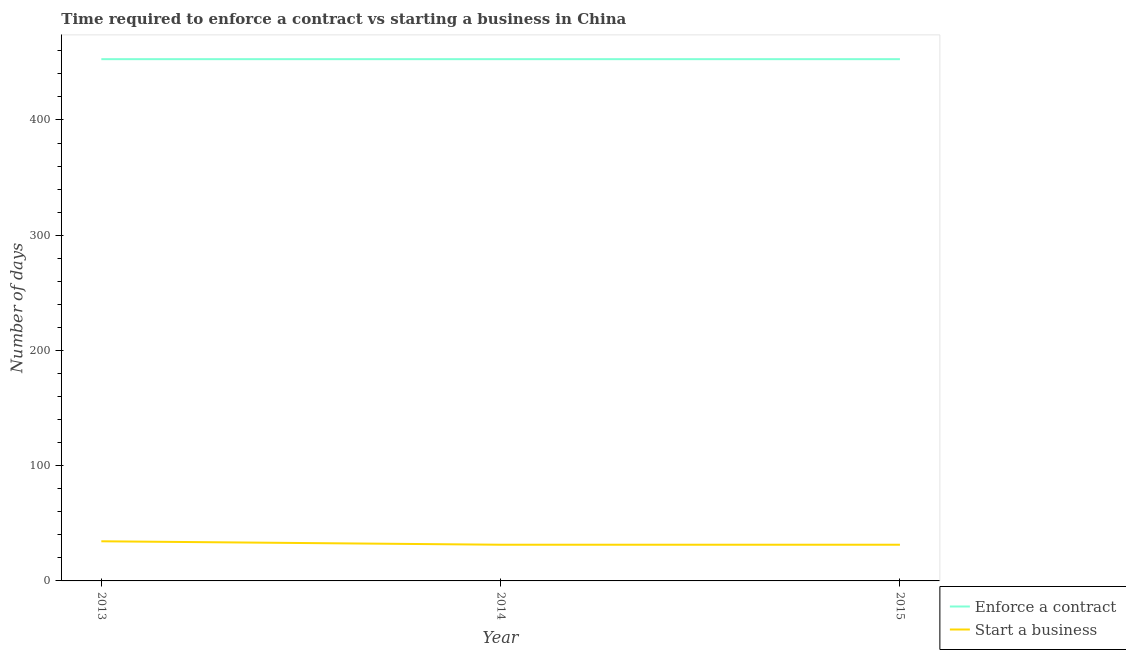How many different coloured lines are there?
Provide a succinct answer. 2. Is the number of lines equal to the number of legend labels?
Ensure brevity in your answer.  Yes. What is the number of days to start a business in 2013?
Give a very brief answer. 34.4. Across all years, what is the maximum number of days to start a business?
Offer a very short reply. 34.4. Across all years, what is the minimum number of days to enforece a contract?
Make the answer very short. 452.8. In which year was the number of days to enforece a contract minimum?
Ensure brevity in your answer.  2013. What is the total number of days to enforece a contract in the graph?
Your answer should be very brief. 1358.4. What is the difference between the number of days to enforece a contract in 2013 and that in 2015?
Offer a very short reply. 0. What is the difference between the number of days to start a business in 2013 and the number of days to enforece a contract in 2014?
Give a very brief answer. -418.4. What is the average number of days to enforece a contract per year?
Your answer should be compact. 452.8. In the year 2013, what is the difference between the number of days to enforece a contract and number of days to start a business?
Ensure brevity in your answer.  418.4. In how many years, is the number of days to enforece a contract greater than 200 days?
Make the answer very short. 3. What is the ratio of the number of days to start a business in 2013 to that in 2014?
Give a very brief answer. 1.1. Is the difference between the number of days to start a business in 2013 and 2015 greater than the difference between the number of days to enforece a contract in 2013 and 2015?
Offer a very short reply. Yes. What is the difference between the highest and the second highest number of days to enforece a contract?
Your response must be concise. 0. Is the sum of the number of days to start a business in 2013 and 2015 greater than the maximum number of days to enforece a contract across all years?
Your answer should be compact. No. Is the number of days to enforece a contract strictly greater than the number of days to start a business over the years?
Make the answer very short. Yes. Is the number of days to enforece a contract strictly less than the number of days to start a business over the years?
Keep it short and to the point. No. How many lines are there?
Your answer should be very brief. 2. What is the difference between two consecutive major ticks on the Y-axis?
Provide a succinct answer. 100. Are the values on the major ticks of Y-axis written in scientific E-notation?
Your answer should be compact. No. Does the graph contain any zero values?
Offer a terse response. No. Where does the legend appear in the graph?
Ensure brevity in your answer.  Bottom right. What is the title of the graph?
Provide a short and direct response. Time required to enforce a contract vs starting a business in China. What is the label or title of the Y-axis?
Your answer should be compact. Number of days. What is the Number of days of Enforce a contract in 2013?
Offer a very short reply. 452.8. What is the Number of days in Start a business in 2013?
Offer a very short reply. 34.4. What is the Number of days of Enforce a contract in 2014?
Your response must be concise. 452.8. What is the Number of days in Start a business in 2014?
Your answer should be compact. 31.4. What is the Number of days in Enforce a contract in 2015?
Make the answer very short. 452.8. What is the Number of days of Start a business in 2015?
Offer a very short reply. 31.4. Across all years, what is the maximum Number of days of Enforce a contract?
Your response must be concise. 452.8. Across all years, what is the maximum Number of days of Start a business?
Give a very brief answer. 34.4. Across all years, what is the minimum Number of days in Enforce a contract?
Keep it short and to the point. 452.8. Across all years, what is the minimum Number of days in Start a business?
Your answer should be compact. 31.4. What is the total Number of days in Enforce a contract in the graph?
Give a very brief answer. 1358.4. What is the total Number of days in Start a business in the graph?
Provide a succinct answer. 97.2. What is the difference between the Number of days of Start a business in 2013 and that in 2014?
Offer a very short reply. 3. What is the difference between the Number of days of Start a business in 2013 and that in 2015?
Give a very brief answer. 3. What is the difference between the Number of days of Start a business in 2014 and that in 2015?
Your answer should be compact. 0. What is the difference between the Number of days of Enforce a contract in 2013 and the Number of days of Start a business in 2014?
Your answer should be compact. 421.4. What is the difference between the Number of days of Enforce a contract in 2013 and the Number of days of Start a business in 2015?
Your response must be concise. 421.4. What is the difference between the Number of days in Enforce a contract in 2014 and the Number of days in Start a business in 2015?
Offer a terse response. 421.4. What is the average Number of days of Enforce a contract per year?
Provide a short and direct response. 452.8. What is the average Number of days of Start a business per year?
Offer a terse response. 32.4. In the year 2013, what is the difference between the Number of days of Enforce a contract and Number of days of Start a business?
Your answer should be very brief. 418.4. In the year 2014, what is the difference between the Number of days of Enforce a contract and Number of days of Start a business?
Your answer should be very brief. 421.4. In the year 2015, what is the difference between the Number of days of Enforce a contract and Number of days of Start a business?
Provide a short and direct response. 421.4. What is the ratio of the Number of days of Enforce a contract in 2013 to that in 2014?
Give a very brief answer. 1. What is the ratio of the Number of days in Start a business in 2013 to that in 2014?
Make the answer very short. 1.1. What is the ratio of the Number of days of Enforce a contract in 2013 to that in 2015?
Keep it short and to the point. 1. What is the ratio of the Number of days in Start a business in 2013 to that in 2015?
Make the answer very short. 1.1. What is the ratio of the Number of days in Enforce a contract in 2014 to that in 2015?
Provide a succinct answer. 1. What is the difference between the highest and the second highest Number of days in Enforce a contract?
Your answer should be very brief. 0. What is the difference between the highest and the lowest Number of days of Enforce a contract?
Keep it short and to the point. 0. 